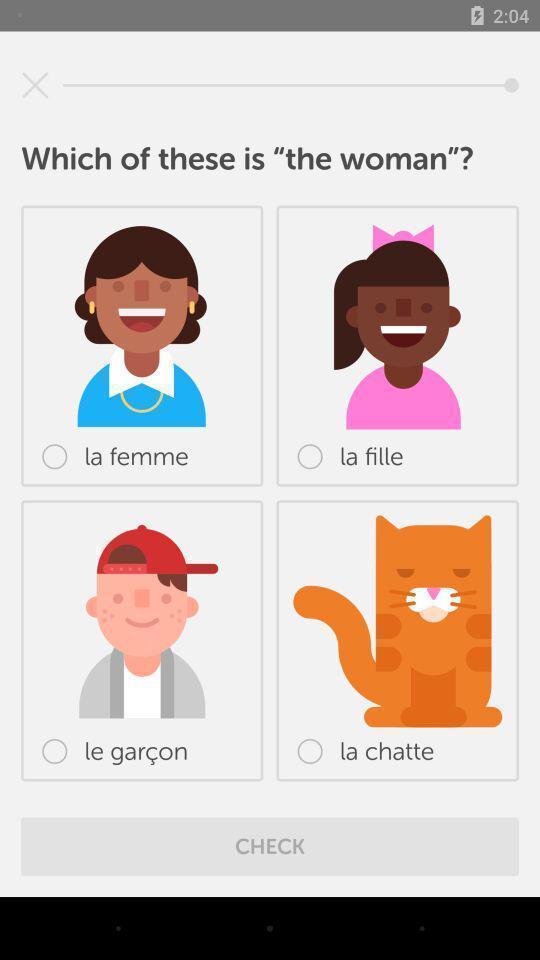Describe the visual elements of this screenshot. Screen showing page of an language learning application. 